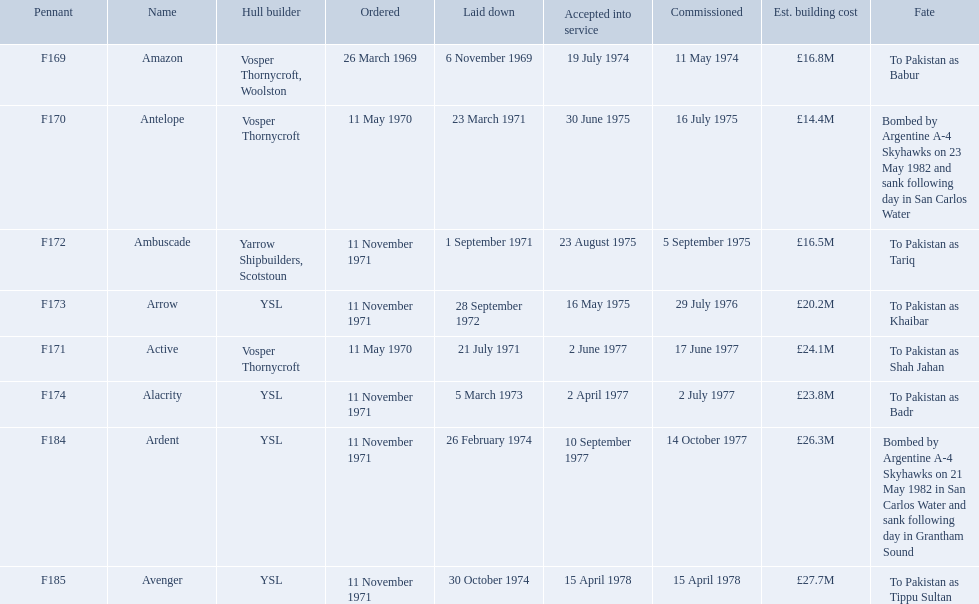What is the last name listed on this chart? Avenger. 